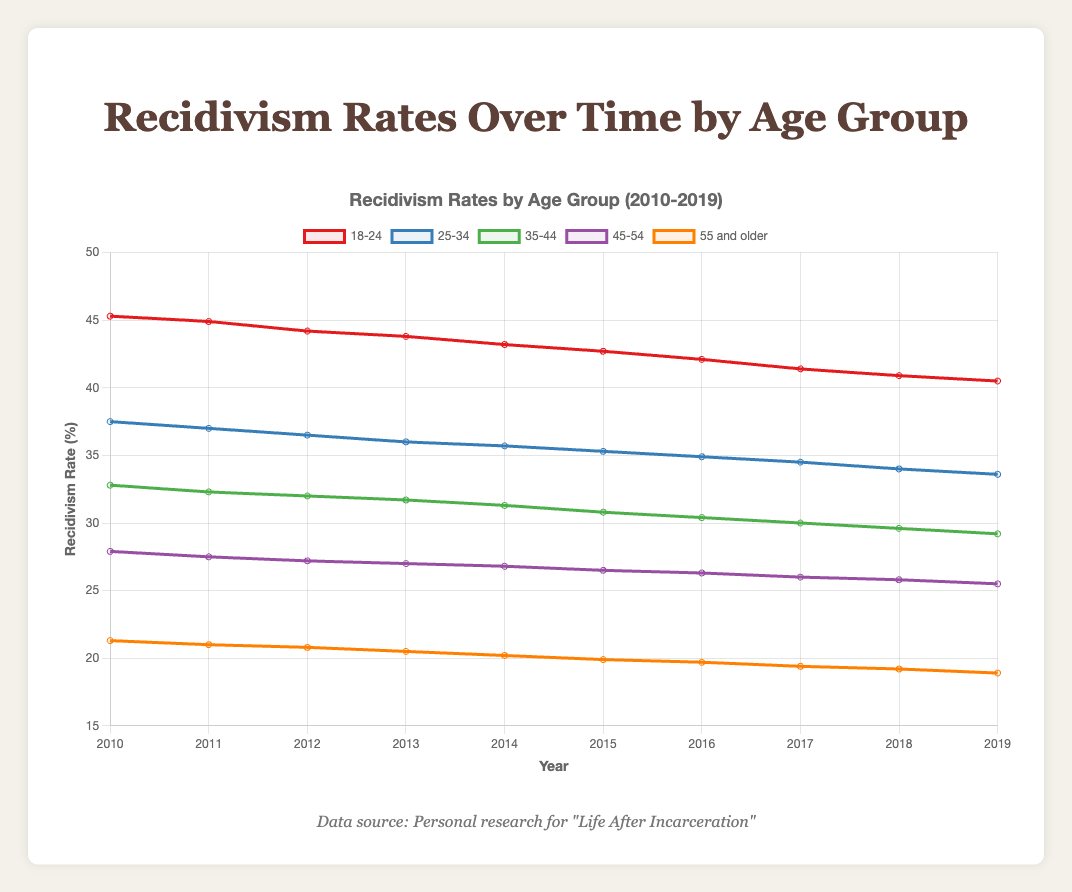What is the general trend in recidivism rates for the age group 18-24 from 2010 to 2019? The recidivism rate for the age group 18-24 shows a consistent decreasing trend over the period 2010 to 2019. In 2010, the rate was 45.3%, and it decreased to 40.5% by 2019. This indicates a steady decline over the decade.
Answer: A consistent decreasing trend Which age group had the highest recidivism rate in 2019? In 2019, the age group 18-24 had the highest recidivism rate at 40.5%. This can be observed by looking at the height of the lines representing each age group and noting the one at the top.
Answer: Age group 18-24 By how much did the recidivism rate for the age group 25-34 change from 2010 to 2019? In 2010, the recidivism rate for the age group 25-34 was 37.5%, and by 2019, it had decreased to 33.6%. The change can be calculated as 37.5% - 33.6% = 3.9%.
Answer: 3.9% Which age group experienced the smallest decrease in recidivism rate from 2010 to 2019? To determine this, we calculate the decrease for each age group from 2010 to 2019. The decreases are: 
- Age 18-24: 45.3% - 40.5% = 4.8%
- Age 25-34: 37.5% - 33.6% = 3.9%
- Age 35-44: 32.8% - 29.2% = 3.6%
- Age 45-54: 27.9% - 25.5% = 2.4%
- Age 55 and older: 21.3% - 18.9% = 2.4%
Both the 45-54 and 55 and older age groups experienced the smallest decrease, which is 2.4%.
Answer: Age groups 45-54 and 55 and older Between which two consecutive years did the recidivism rate for the age group 35-44 decrease the most? We need to calculate the difference between consecutive years for the age group 35-44 and identify the maximum decrease:
- 2010 to 2011: 32.8% - 32.3% = 0.5%
- 2011 to 2012: 32.3% - 32.0% = 0.3%
- 2012 to 2013: 32.0% - 31.7% = 0.3%
- 2013 to 2014: 31.7% - 31.3% = 0.4%
- 2014 to 2015: 31.3% - 30.8% = 0.5%
- 2015 to 2016: 30.8% - 30.4% = 0.4%
- 2016 to 2017: 30.4% - 30.0% = 0.4%
- 2017 to 2018: 30.0% - 29.6% = 0.4%
- 2018 to 2019: 29.6% - 29.2% = 0.4%
The largest decrease is 0.5%, which occurred between 2010-2011 and 2014-2015.
Answer: 2010-2011 and 2014-2015 